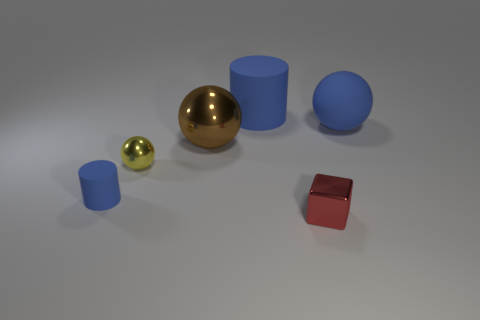Add 4 big rubber cylinders. How many objects exist? 10 Subtract all large blue rubber spheres. How many spheres are left? 2 Subtract 2 cylinders. How many cylinders are left? 0 Subtract all brown blocks. Subtract all red cylinders. How many blocks are left? 1 Subtract all brown cylinders. How many purple spheres are left? 0 Subtract all red cubes. Subtract all tiny cylinders. How many objects are left? 4 Add 5 brown objects. How many brown objects are left? 6 Add 1 big things. How many big things exist? 4 Subtract 1 yellow spheres. How many objects are left? 5 Subtract all cylinders. How many objects are left? 4 